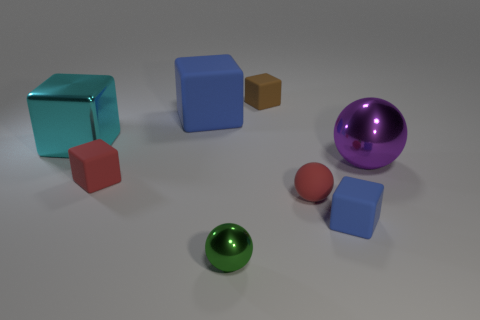There is a big metallic object that is on the right side of the big metal thing that is on the left side of the green metallic thing; what shape is it?
Provide a short and direct response. Sphere. What number of things are blue rubber things behind the tiny red matte ball or shiny balls in front of the purple metal thing?
Give a very brief answer. 2. What is the shape of the small blue object that is made of the same material as the tiny red cube?
Offer a very short reply. Cube. Is there any other thing of the same color as the big rubber block?
Ensure brevity in your answer.  Yes. There is another cyan object that is the same shape as the large matte object; what material is it?
Ensure brevity in your answer.  Metal. How many other things are there of the same size as the brown block?
Your response must be concise. 4. What is the brown thing made of?
Ensure brevity in your answer.  Rubber. Is the number of metal objects right of the brown matte block greater than the number of tiny red rubber cylinders?
Offer a very short reply. Yes. Is there a large purple ball?
Your answer should be compact. Yes. How many other things are the same shape as the cyan shiny object?
Your answer should be very brief. 4. 